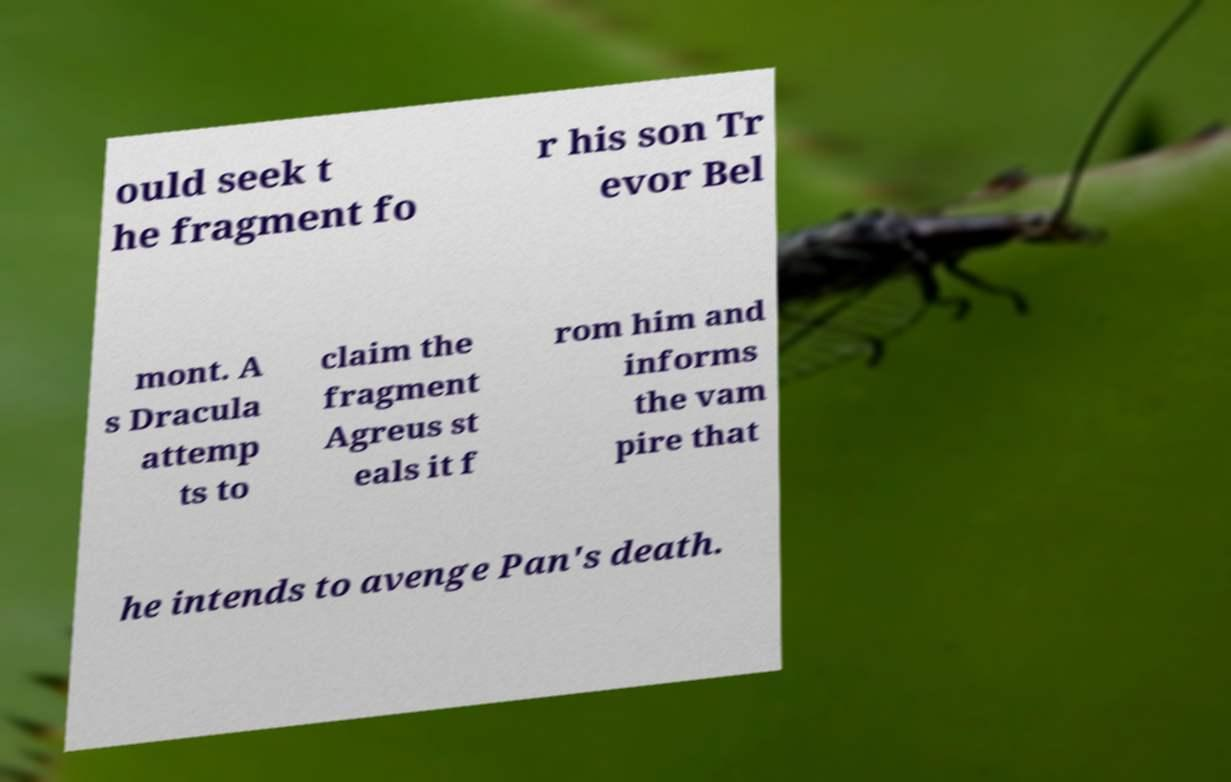Could you assist in decoding the text presented in this image and type it out clearly? ould seek t he fragment fo r his son Tr evor Bel mont. A s Dracula attemp ts to claim the fragment Agreus st eals it f rom him and informs the vam pire that he intends to avenge Pan's death. 